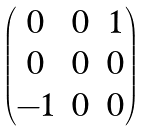Convert formula to latex. <formula><loc_0><loc_0><loc_500><loc_500>\begin{pmatrix} 0 & 0 & 1 \\ 0 & 0 & 0 \\ - 1 & 0 & 0 \end{pmatrix}</formula> 